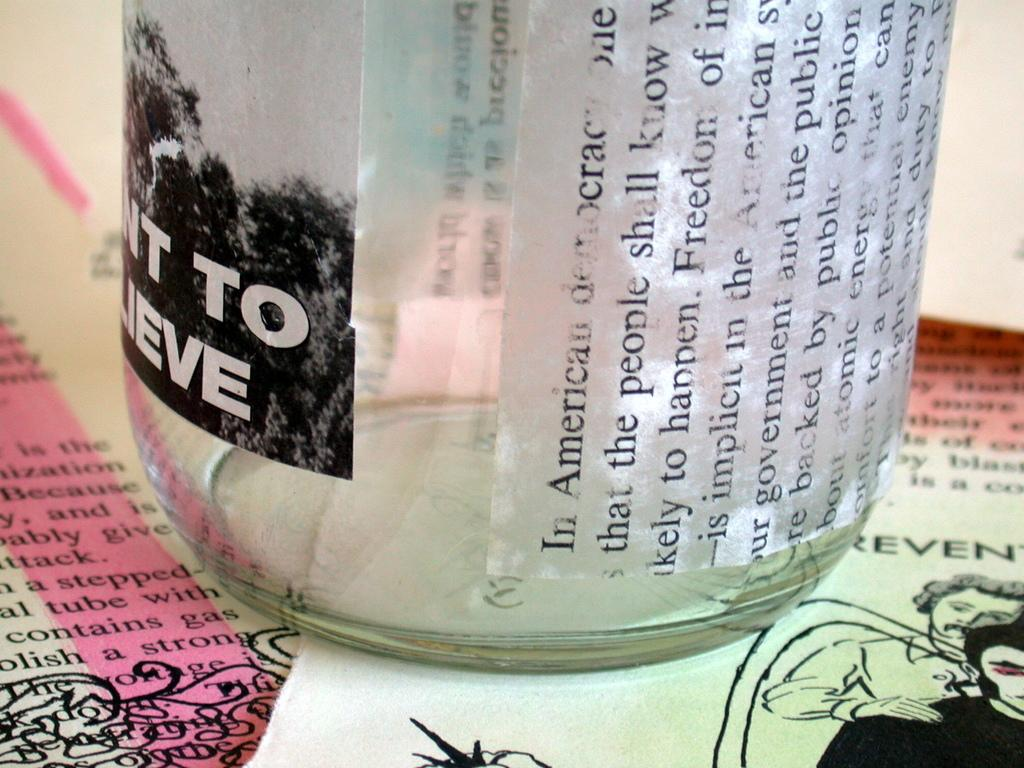What object is visible on top of the papers in the image? There is a bottle on top of the papers in the image. What is written or printed on the bottle? The bottle has text on it. What can be seen on the right side of the image? There are images of two persons on the right side of the image. What is present on the paper besides the bottle? There is text on the paper. What type of plants can be seen growing on the paper in the image? There are no plants visible on the paper in the image. What is the cause of the text on the paper in the image? The cause of the text on the paper cannot be determined from the image alone. 